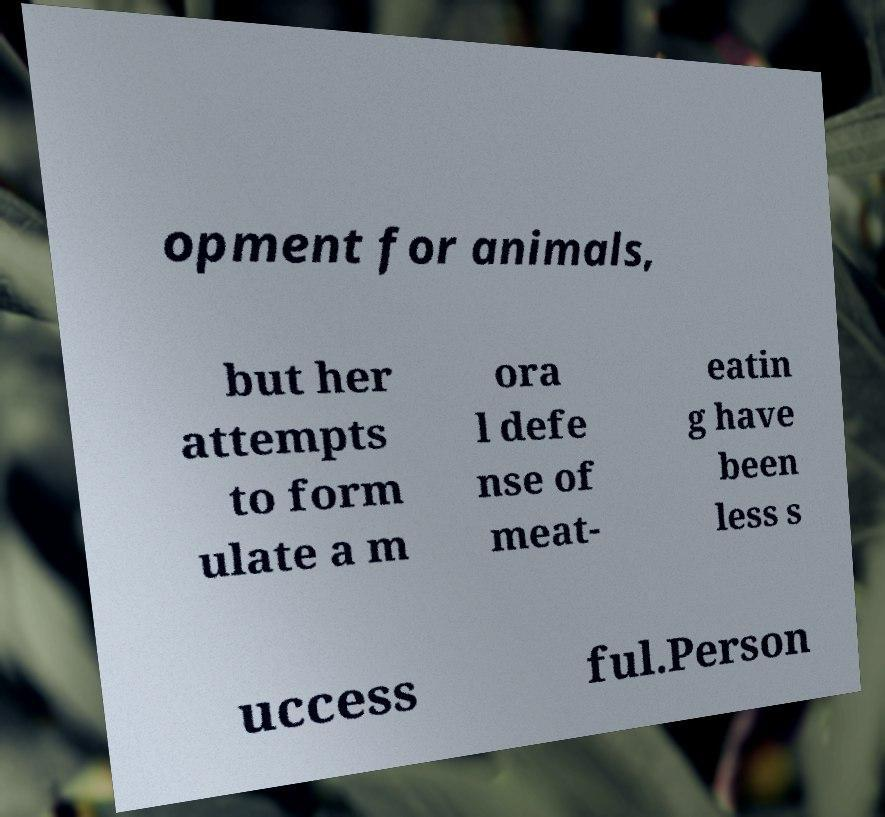Can you read and provide the text displayed in the image?This photo seems to have some interesting text. Can you extract and type it out for me? opment for animals, but her attempts to form ulate a m ora l defe nse of meat- eatin g have been less s uccess ful.Person 